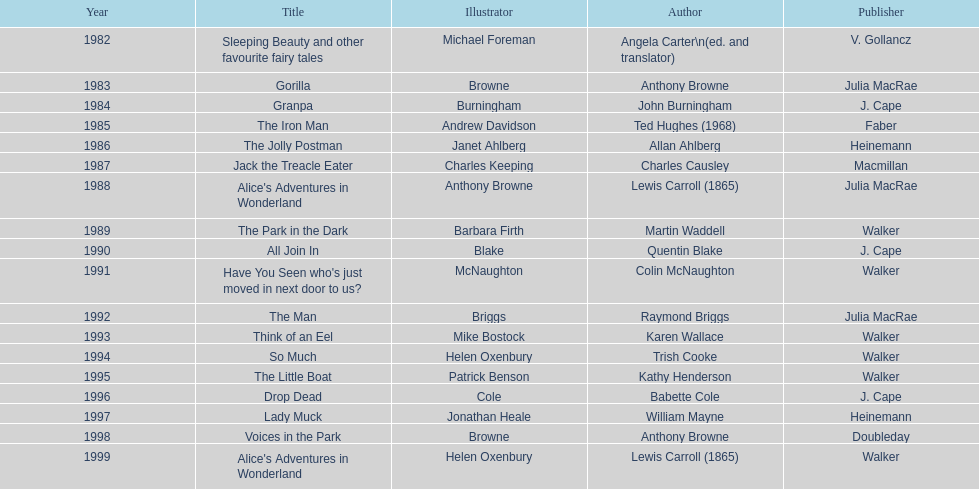How many total titles were published by walker? 5. 